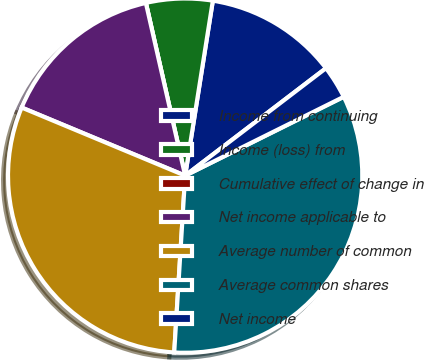<chart> <loc_0><loc_0><loc_500><loc_500><pie_chart><fcel>Income from continuing<fcel>Income (loss) from<fcel>Cumulative effect of change in<fcel>Net income applicable to<fcel>Average number of common<fcel>Average common shares<fcel>Net income<nl><fcel>12.13%<fcel>6.06%<fcel>0.0%<fcel>15.16%<fcel>30.3%<fcel>33.33%<fcel>3.03%<nl></chart> 